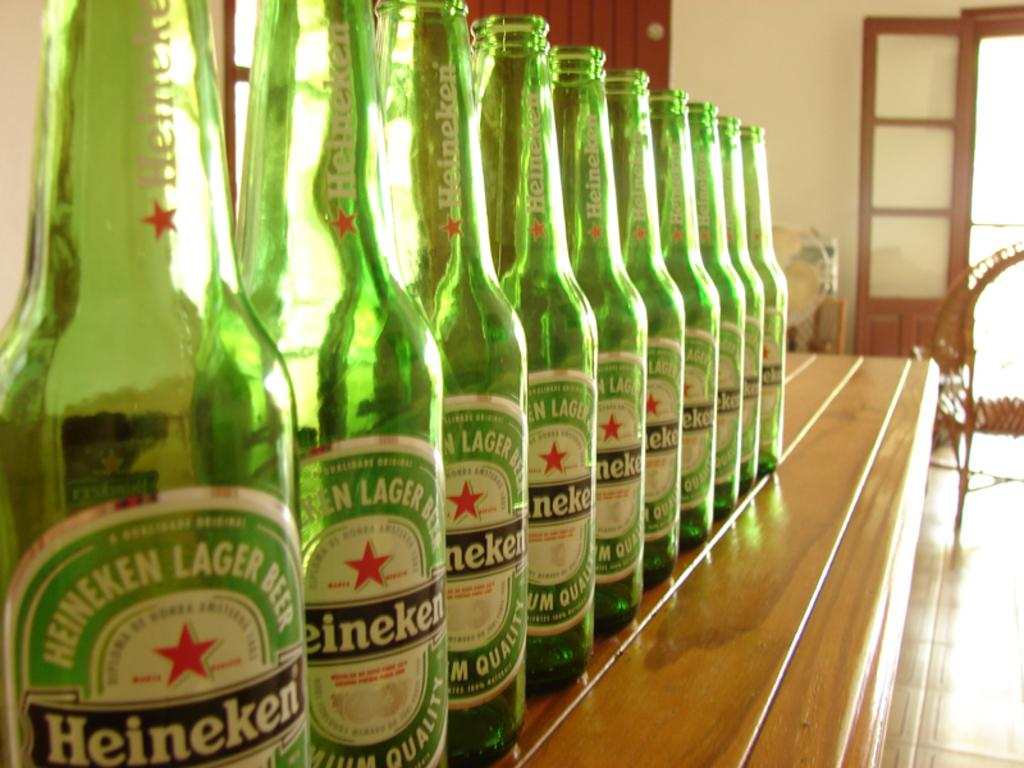What type of beverage containers are on the table in the image? There are wine bottles on the table in the image. What can be seen on the right side of the image? There is a door on the right side of the image. How many members are on the team that is playing with fire in the image? There is no team or fire present in the image; it only features wine bottles on a table and a door on the right side. 